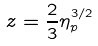Convert formula to latex. <formula><loc_0><loc_0><loc_500><loc_500>z = \frac { 2 } { 3 } \eta _ { p } ^ { 3 / 2 }</formula> 